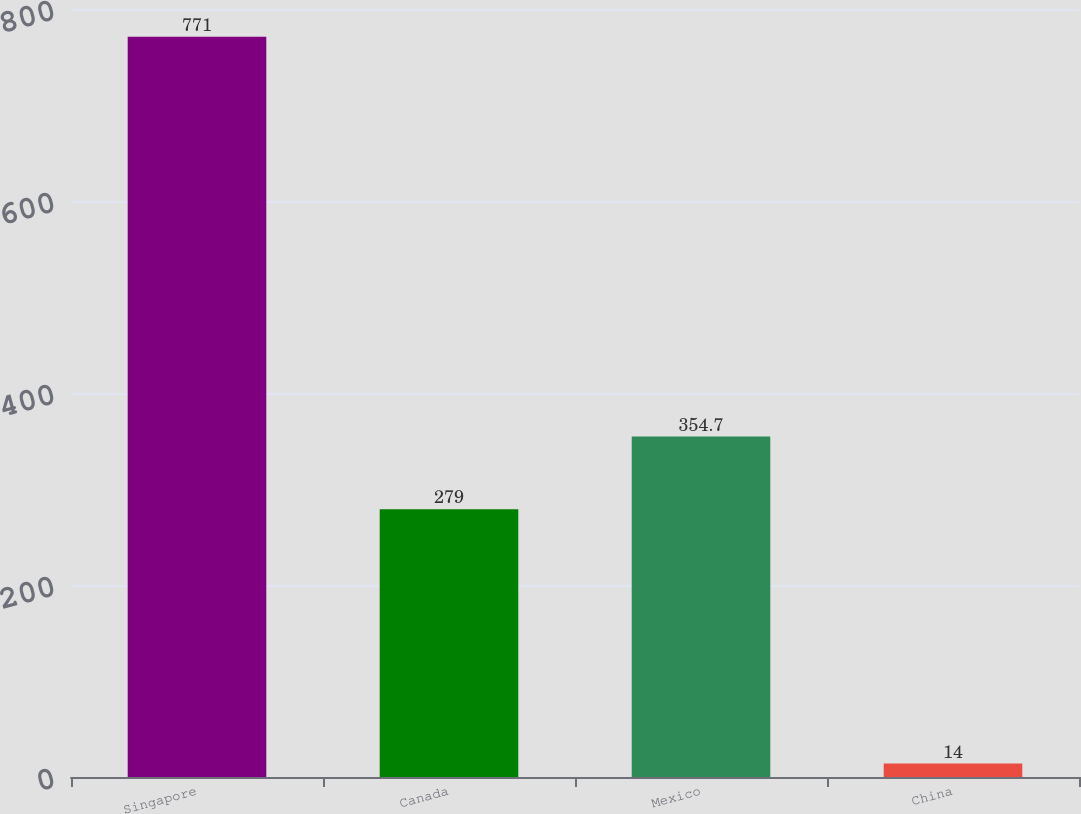Convert chart. <chart><loc_0><loc_0><loc_500><loc_500><bar_chart><fcel>Singapore<fcel>Canada<fcel>Mexico<fcel>China<nl><fcel>771<fcel>279<fcel>354.7<fcel>14<nl></chart> 